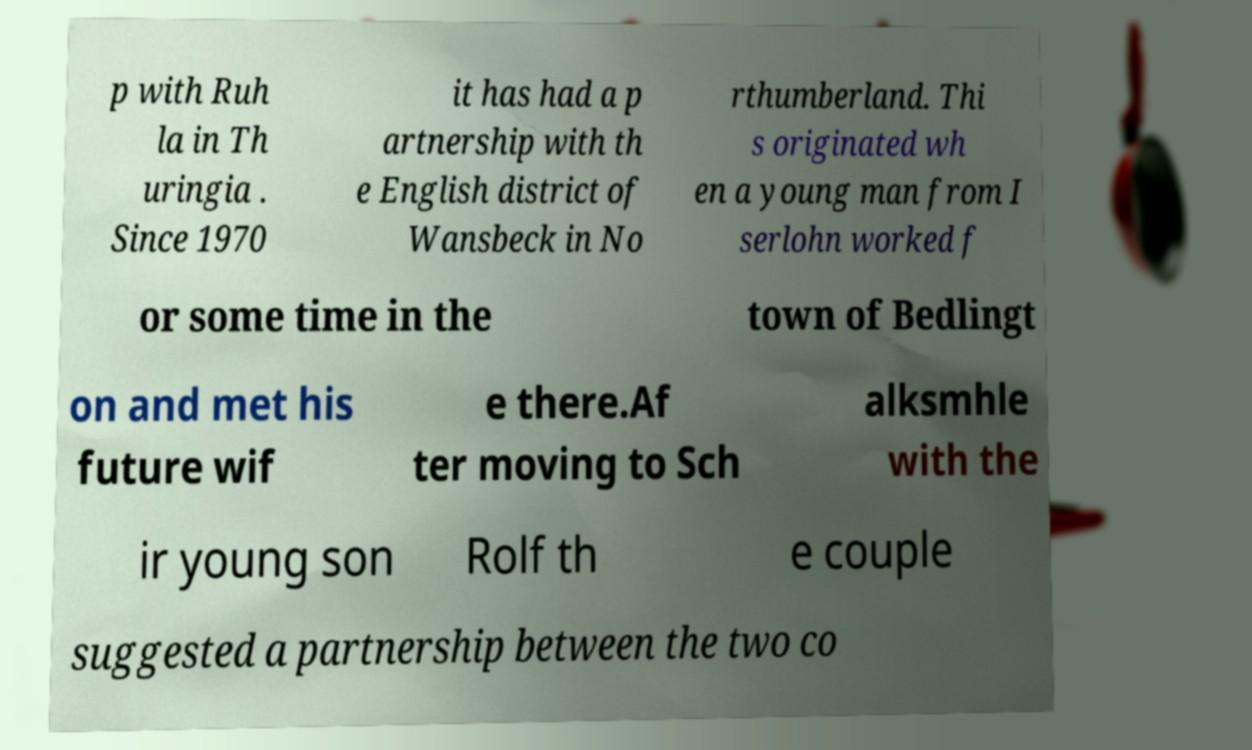Please read and relay the text visible in this image. What does it say? p with Ruh la in Th uringia . Since 1970 it has had a p artnership with th e English district of Wansbeck in No rthumberland. Thi s originated wh en a young man from I serlohn worked f or some time in the town of Bedlingt on and met his future wif e there.Af ter moving to Sch alksmhle with the ir young son Rolf th e couple suggested a partnership between the two co 